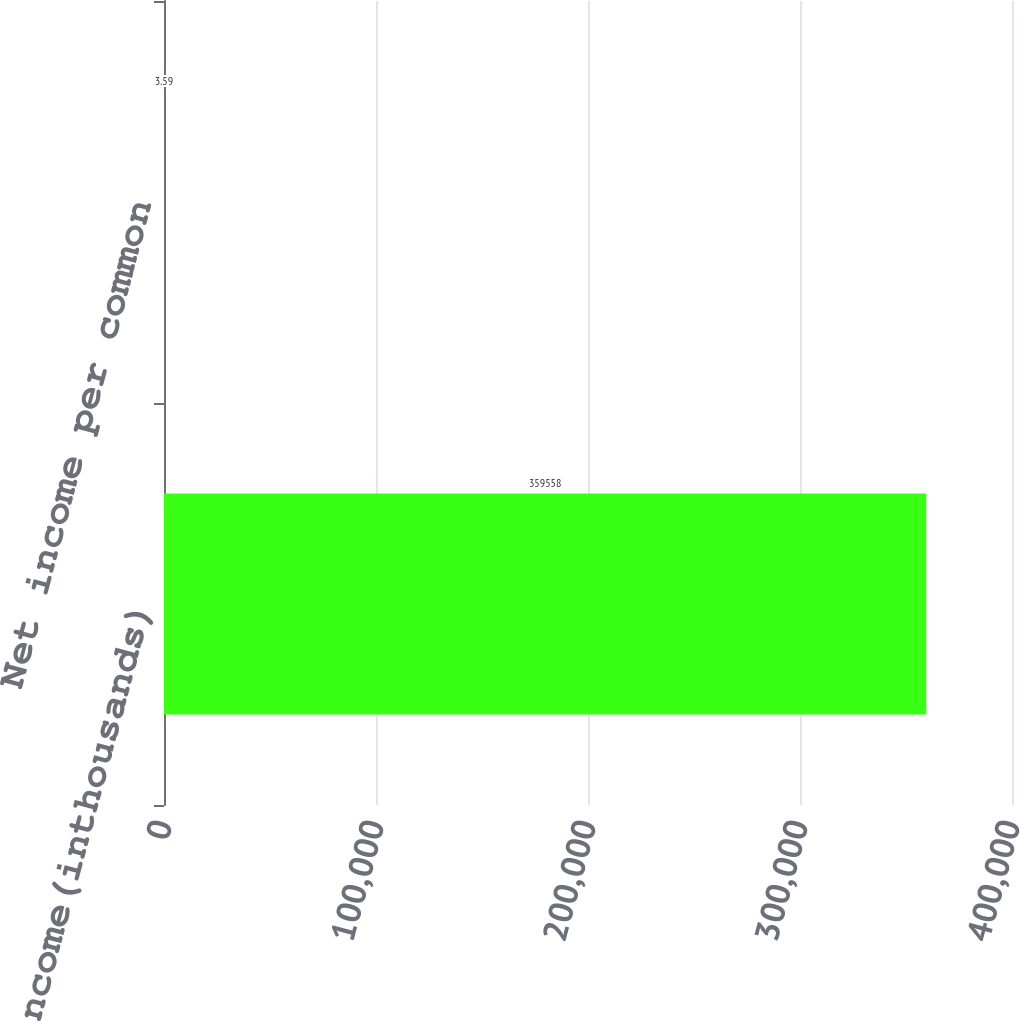<chart> <loc_0><loc_0><loc_500><loc_500><bar_chart><fcel>Netincome(inthousands)<fcel>Net income per common<nl><fcel>359558<fcel>3.59<nl></chart> 